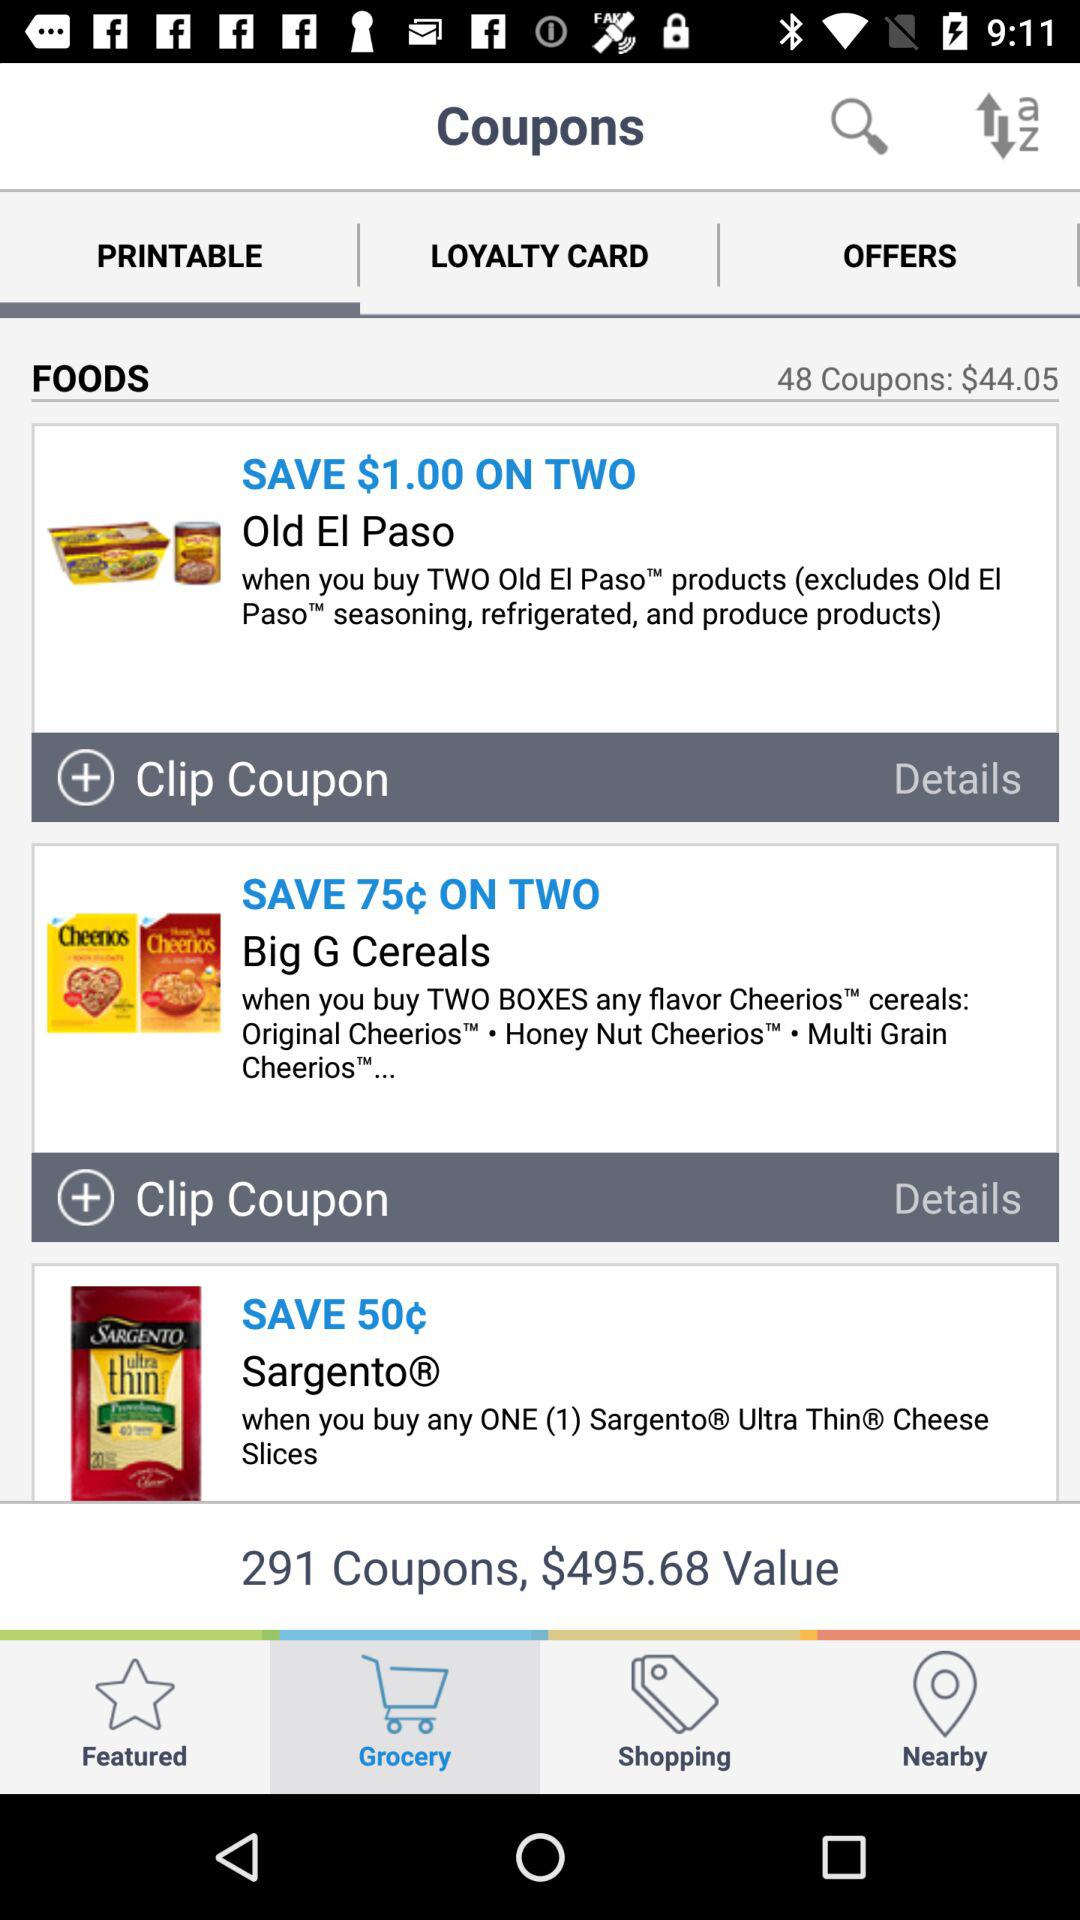What is the total count of coupons? The total count of coupons is 291. 